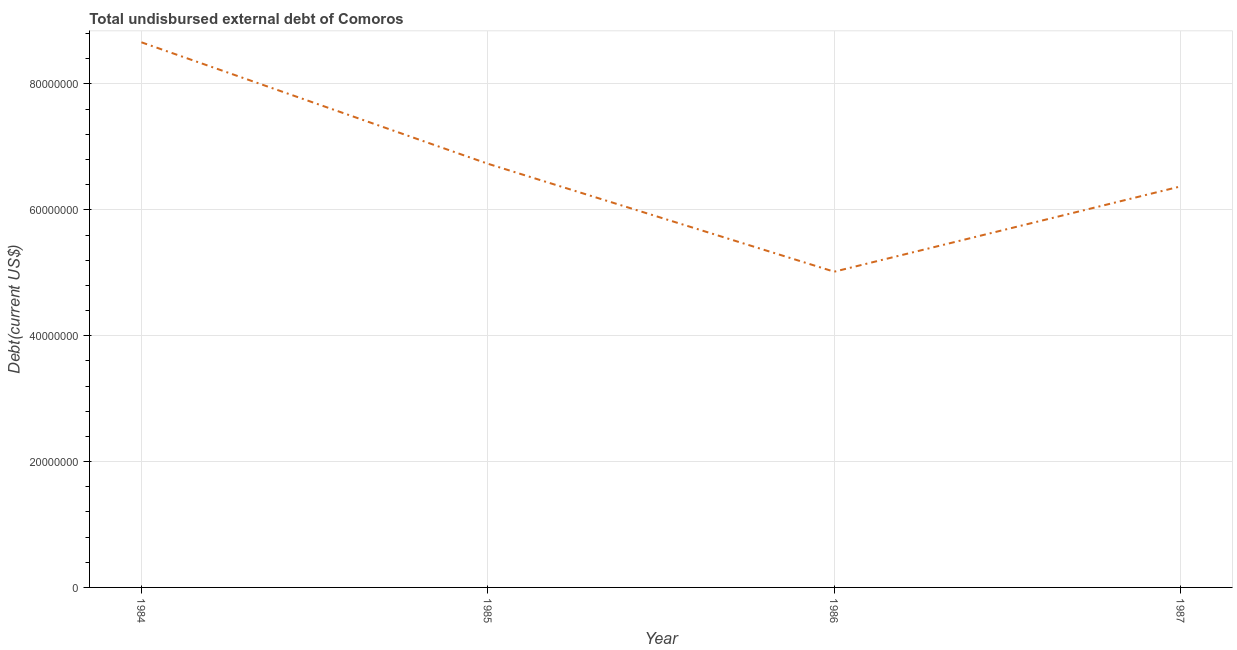What is the total debt in 1987?
Provide a succinct answer. 6.37e+07. Across all years, what is the maximum total debt?
Your response must be concise. 8.66e+07. Across all years, what is the minimum total debt?
Your response must be concise. 5.02e+07. What is the sum of the total debt?
Provide a short and direct response. 2.68e+08. What is the difference between the total debt in 1985 and 1987?
Make the answer very short. 3.61e+06. What is the average total debt per year?
Your answer should be compact. 6.70e+07. What is the median total debt?
Offer a terse response. 6.55e+07. Do a majority of the years between 1986 and 1984 (inclusive) have total debt greater than 8000000 US$?
Provide a short and direct response. No. What is the ratio of the total debt in 1985 to that in 1986?
Make the answer very short. 1.34. What is the difference between the highest and the second highest total debt?
Make the answer very short. 1.93e+07. Is the sum of the total debt in 1985 and 1986 greater than the maximum total debt across all years?
Offer a very short reply. Yes. What is the difference between the highest and the lowest total debt?
Keep it short and to the point. 3.65e+07. How many lines are there?
Make the answer very short. 1. How many years are there in the graph?
Offer a very short reply. 4. Are the values on the major ticks of Y-axis written in scientific E-notation?
Your answer should be compact. No. What is the title of the graph?
Your response must be concise. Total undisbursed external debt of Comoros. What is the label or title of the X-axis?
Offer a terse response. Year. What is the label or title of the Y-axis?
Keep it short and to the point. Debt(current US$). What is the Debt(current US$) in 1984?
Offer a very short reply. 8.66e+07. What is the Debt(current US$) in 1985?
Keep it short and to the point. 6.73e+07. What is the Debt(current US$) in 1986?
Offer a terse response. 5.02e+07. What is the Debt(current US$) of 1987?
Your answer should be compact. 6.37e+07. What is the difference between the Debt(current US$) in 1984 and 1985?
Keep it short and to the point. 1.93e+07. What is the difference between the Debt(current US$) in 1984 and 1986?
Give a very brief answer. 3.65e+07. What is the difference between the Debt(current US$) in 1984 and 1987?
Offer a very short reply. 2.29e+07. What is the difference between the Debt(current US$) in 1985 and 1986?
Ensure brevity in your answer.  1.72e+07. What is the difference between the Debt(current US$) in 1985 and 1987?
Make the answer very short. 3.61e+06. What is the difference between the Debt(current US$) in 1986 and 1987?
Keep it short and to the point. -1.36e+07. What is the ratio of the Debt(current US$) in 1984 to that in 1985?
Your answer should be compact. 1.29. What is the ratio of the Debt(current US$) in 1984 to that in 1986?
Ensure brevity in your answer.  1.73. What is the ratio of the Debt(current US$) in 1984 to that in 1987?
Offer a terse response. 1.36. What is the ratio of the Debt(current US$) in 1985 to that in 1986?
Ensure brevity in your answer.  1.34. What is the ratio of the Debt(current US$) in 1985 to that in 1987?
Make the answer very short. 1.06. What is the ratio of the Debt(current US$) in 1986 to that in 1987?
Your answer should be compact. 0.79. 